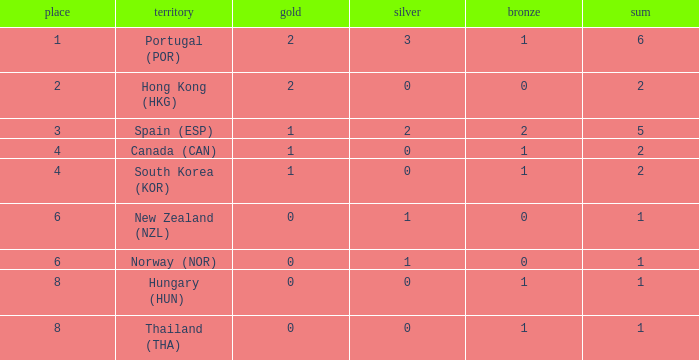Which Rank number has a Silver of 0, Gold of 2 and total smaller than 2? 0.0. 